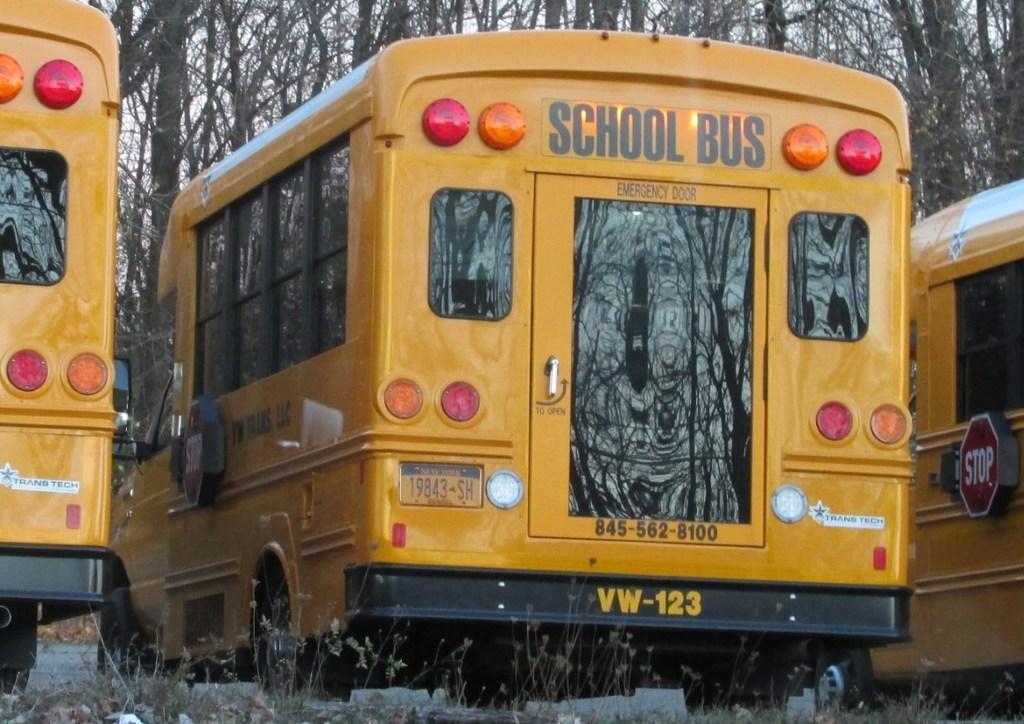Can you describe this image briefly? In this picture we can see buses on the ground with signboards on it, plants and in the background we can see trees. 